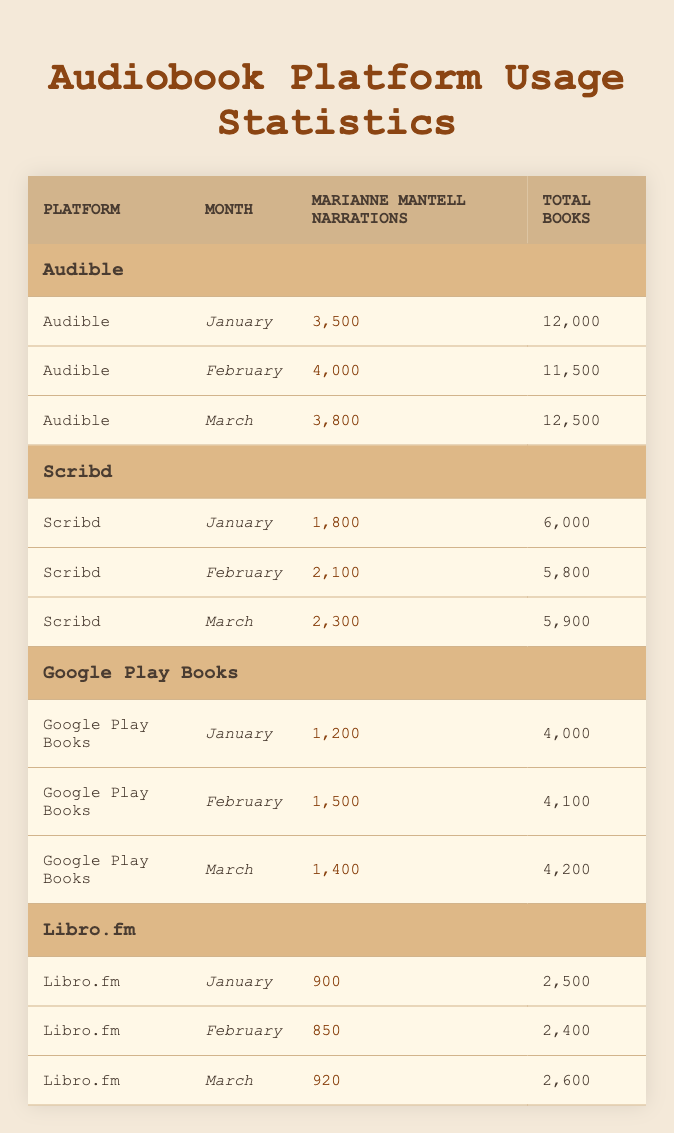What was the highest number of Marianne Mantell narrations on Audible in a single month? From the table, we can see the numbers of narrations for each month on Audible: January (3500), February (4000), and March (3800). The highest number is 4000 in February.
Answer: 4000 How many total books were available in March on Google Play Books? According to the table, the total number of books available on Google Play Books in March is listed as 4200.
Answer: 4200 What is the total number of Marianne Mantell narrations across all platforms for January? First, we find the narrations for each platform in January: Audible (3500), Scribd (1800), Google Play Books (1200), and Libro.fm (900). Summing these values gives: 3500 + 1800 + 1200 + 900 = 6400.
Answer: 6400 Did Scribd have more than 2000 Marianne Mantell narrations in February? Looking at the data, Scribd had 2100 narrations in February, which is indeed greater than 2000. Thus, the answer is true.
Answer: Yes Which audiobook platform had the least number of Marianne Mantell narrations in March? The narrations for March are: Audible (3800), Scribd (2300), Google Play Books (1400), and Libro.fm (920). The platform with the least is Libro.fm with 920 narrations.
Answer: Libro.fm What was the average number of Marianne Mantell narrations on Scribd over the three months? The figures for Scribd are: January (1800), February (2100), and March (2300). To compute the average, we sum these values: 1800 + 2100 + 2300 = 6200 and divide by 3, which results in 6200/3 ≈ 2066.67.
Answer: Approximately 2067 How many total narrations were recorded on Libro.fm from January to March combined? The narrations for Libro.fm are: January (900), February (850), and March (920). The total is 900 + 850 + 920 = 2670.
Answer: 2670 Was the total number of narrations for Marianne Mantell higher on Audible than on Scribd in January? In January, Audible had 3500 narrations and Scribd had 1800. Since 3500 is greater than 1800, the answer is true.
Answer: Yes Which platform saw the highest increase in Marianne Mantell narrations from January to February? We look at the increases: Audible increased from 3500 to 4000 (+500), Scribd from 1800 to 2100 (+300), Google Play Books from 1200 to 1500 (+300), and Libro.fm from 900 to 850 (-50). The highest increase is 500 on Audible.
Answer: Audible 